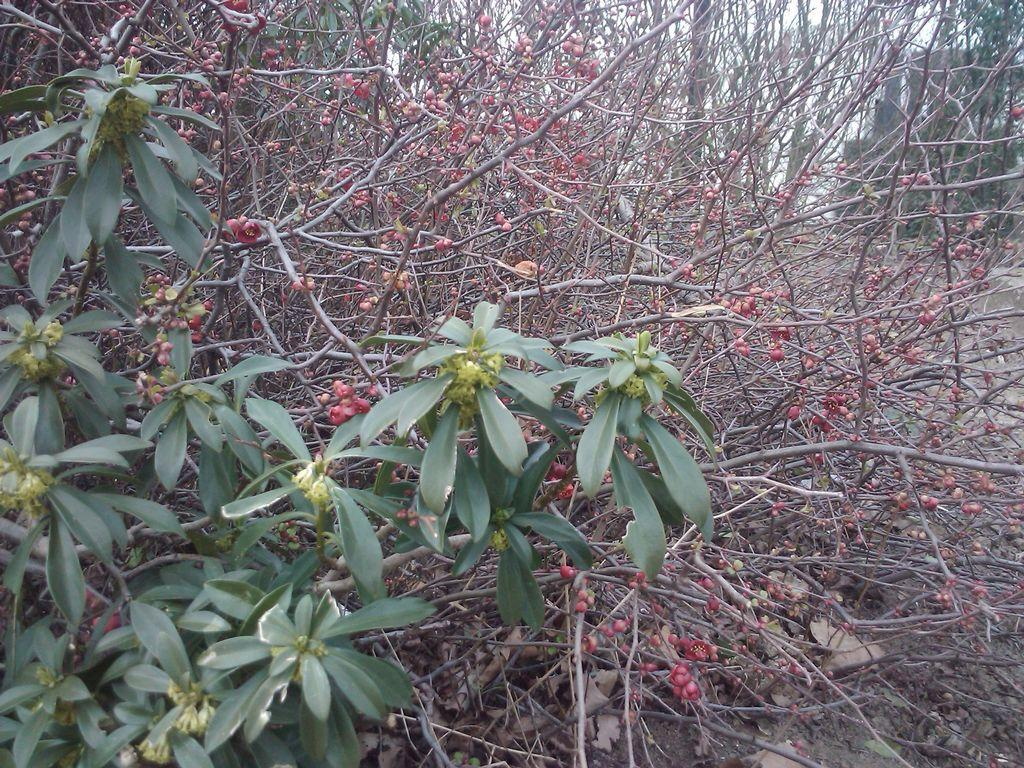What type of vegetation is on the left side of the image? There are trees on the left side of the image. What type of hair can be seen on the trees in the image? There is no hair present on the trees in the image; they are simply trees with leaves or branches. 